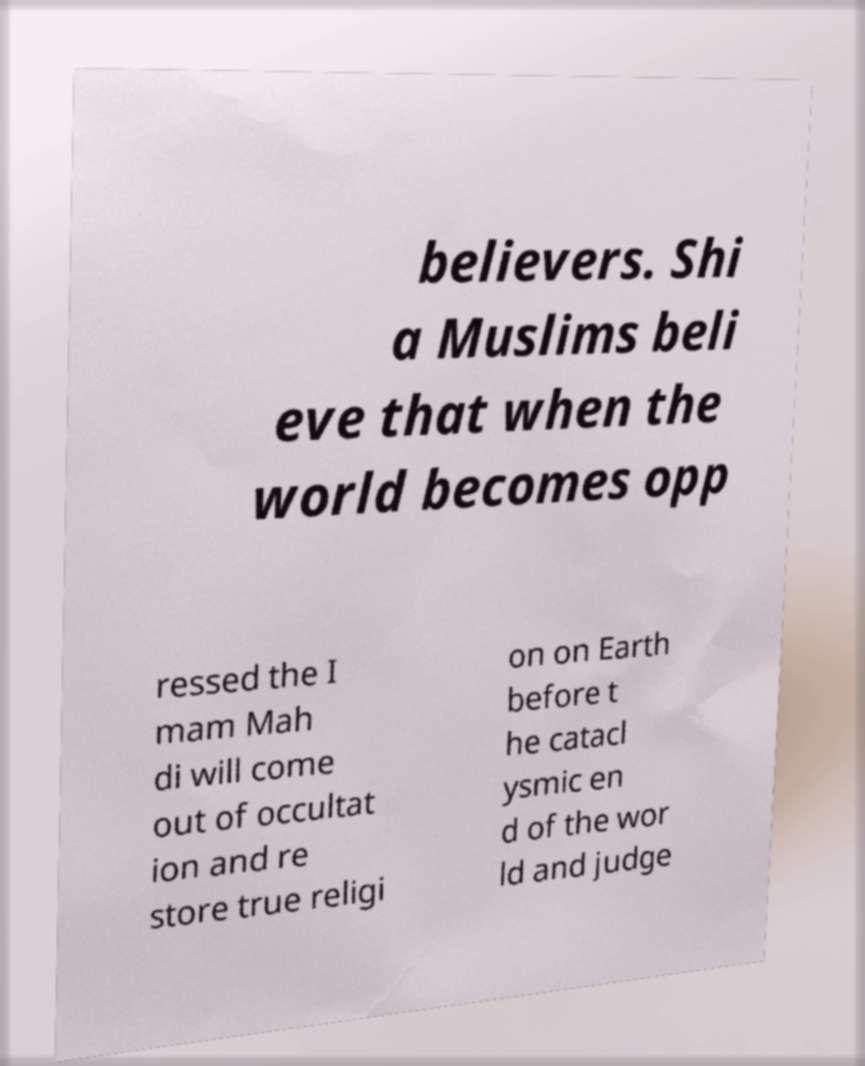Can you read and provide the text displayed in the image?This photo seems to have some interesting text. Can you extract and type it out for me? believers. Shi a Muslims beli eve that when the world becomes opp ressed the I mam Mah di will come out of occultat ion and re store true religi on on Earth before t he catacl ysmic en d of the wor ld and judge 